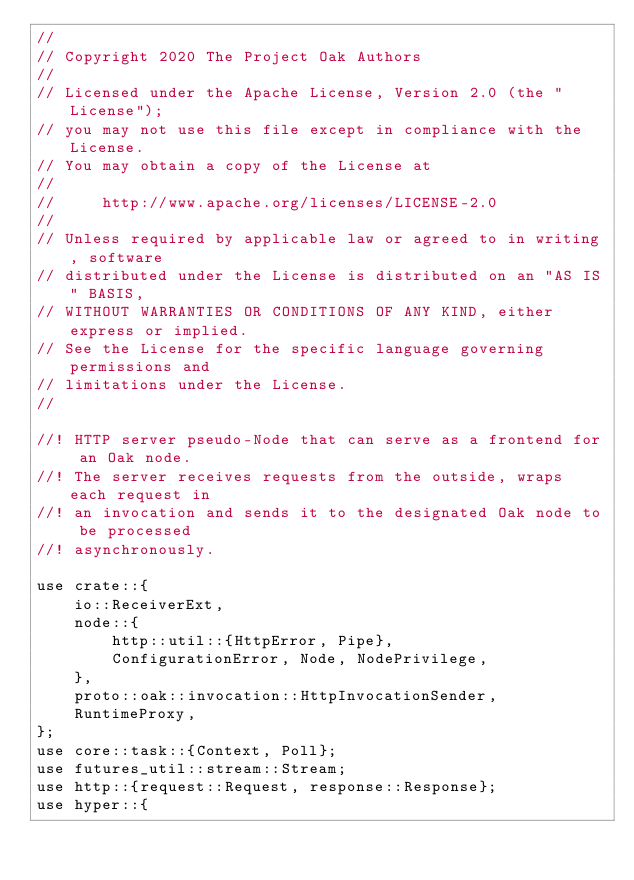Convert code to text. <code><loc_0><loc_0><loc_500><loc_500><_Rust_>//
// Copyright 2020 The Project Oak Authors
//
// Licensed under the Apache License, Version 2.0 (the "License");
// you may not use this file except in compliance with the License.
// You may obtain a copy of the License at
//
//     http://www.apache.org/licenses/LICENSE-2.0
//
// Unless required by applicable law or agreed to in writing, software
// distributed under the License is distributed on an "AS IS" BASIS,
// WITHOUT WARRANTIES OR CONDITIONS OF ANY KIND, either express or implied.
// See the License for the specific language governing permissions and
// limitations under the License.
//

//! HTTP server pseudo-Node that can serve as a frontend for an Oak node.
//! The server receives requests from the outside, wraps each request in
//! an invocation and sends it to the designated Oak node to be processed
//! asynchronously.

use crate::{
    io::ReceiverExt,
    node::{
        http::util::{HttpError, Pipe},
        ConfigurationError, Node, NodePrivilege,
    },
    proto::oak::invocation::HttpInvocationSender,
    RuntimeProxy,
};
use core::task::{Context, Poll};
use futures_util::stream::Stream;
use http::{request::Request, response::Response};
use hyper::{</code> 